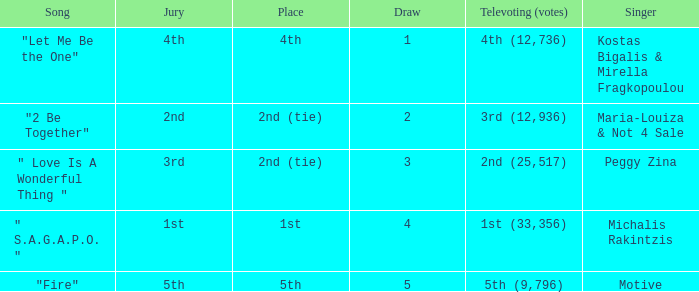What melody was 2nd (25,517) in televoting (votes)? " Love Is A Wonderful Thing ". 